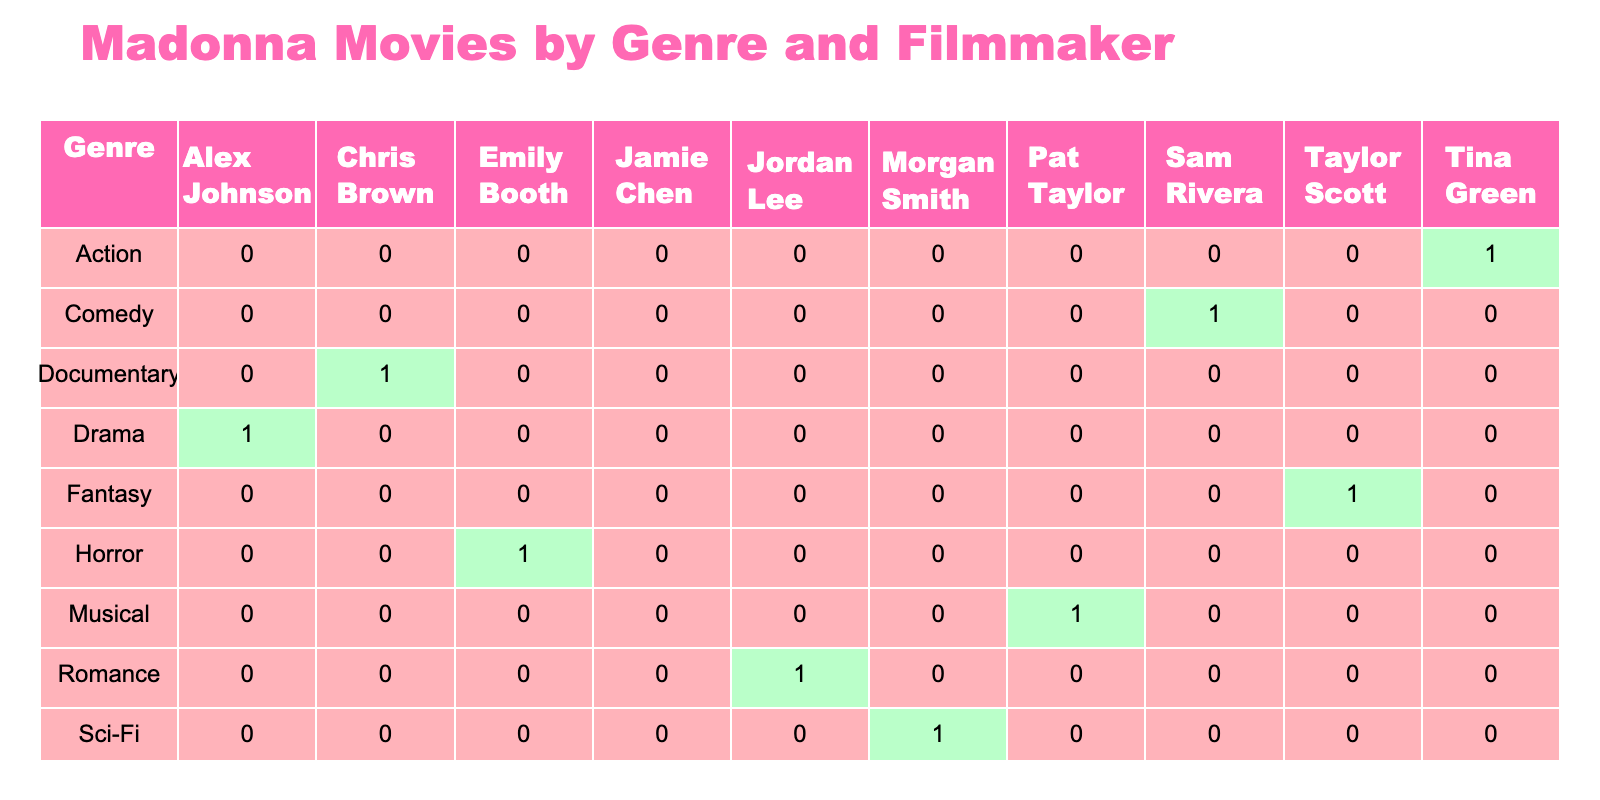What genre has the most movies directed by amateur filmmakers starring Madonna? To find the genre with the most movies, we look at the column totals for each genre in the table. Counting the movies, we see that Comedy, with one movie (Material Girl), and Drama, horror, romance, action, documentary, musical, sci-fi, thriller, and fantasy all have one movie each. Therefore, there is no genre that stands out with more than one entry.
Answer: None Are there more horror movies or comedy movies directed by amateur filmmakers starring Madonna? The table shows that there is 1 horror movie (Shadow of the Night) and 1 comedy movie (Material Girl). Since both have the same count, they are equal.
Answer: Equal Which filmmaker has directed the action genre movie? In the table, there is one entry for the action genre which is "Rebel Heart" directed by Tina Green.
Answer: Tina Green How many filmmakers directed movies in the genre of romance? The table shows one entry for the romance genre, which is "The Dance" by Jordan Lee. Therefore, there is only one filmmaker associated with this genre.
Answer: 1 Is there a documentary movie directed by an amateur filmmaker starring Madonna? Yes, the table lists "Living for Love" directed by Chris Brown under the documentary genre, confirming that there is a documentary movie.
Answer: Yes How many different genres are represented in the table? By counting the unique genre entries in the table, we identify Drama, Comedy, Horror, Romance, Action, Documentary, Musical, Sci-Fi, Thriller, and Fantasy, totaling 10 different genres represented.
Answer: 10 Which genre has the least number of movies directed by amateur filmmakers starring Madonna? Looking at the table, all genres in the dataset have only one entry, indicating that there is no genre with fewer entries than any other. Hence, all genres have an equal representation.
Answer: None What is the total number of movies directed by filmmakers in the comedy and rom-com genres? The comedy genre (1 movie) and the romance genre (1 movie) each have one film. Adding these together gives a total of 2 movies in the combined genres of comedy and romance.
Answer: 2 Did any filmmakers direct movies in both the comedy and action genres? The table states that Sam Rivera directed the comedy genre and Tina Green directed the action genre, showing there are no filmmakers involved in both genres.
Answer: No 